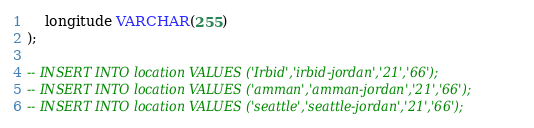<code> <loc_0><loc_0><loc_500><loc_500><_SQL_>    longitude VARCHAR(255)
);

-- INSERT INTO location VALUES ('Irbid','irbid-jordan','21','66');
-- INSERT INTO location VALUES ('amman','amman-jordan','21','66');
-- INSERT INTO location VALUES ('seattle','seattle-jordan','21','66');
</code> 